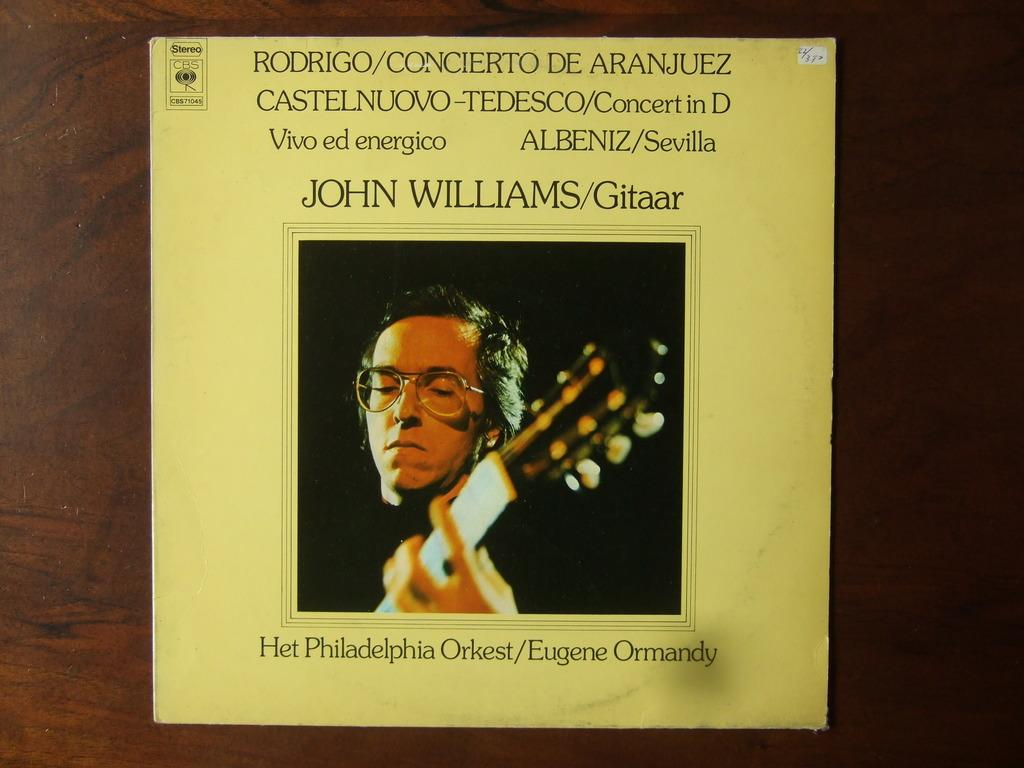What type of image is being described? The image is a poster. Who is featured in the poster? There is a man in the poster. What is the man wearing? The man is wearing spectacles. What is the man holding in the poster? The man is holding a guitar in his hand. What hill can be seen in the background of the poster? There is no hill visible in the poster; it features a man holding a guitar and wearing spectacles. 